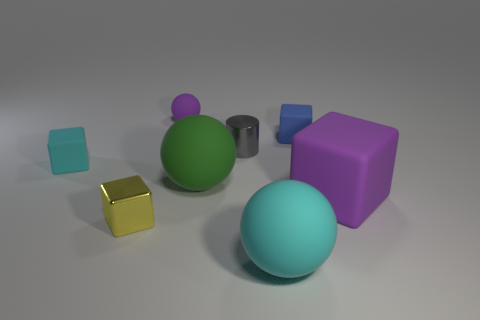There is a tiny ball that is the same color as the big cube; what is its material?
Keep it short and to the point. Rubber. What number of other objects are the same shape as the tiny blue rubber object?
Your answer should be very brief. 3. There is a tiny cube right of the sphere to the left of the green thing in front of the small cyan matte thing; what color is it?
Provide a succinct answer. Blue. How many small things are there?
Provide a short and direct response. 5. How many large things are purple balls or blue metallic cylinders?
Make the answer very short. 0. What is the shape of the purple rubber thing that is the same size as the shiny cube?
Offer a terse response. Sphere. Are there any other things that are the same size as the yellow block?
Offer a terse response. Yes. What is the material of the block that is in front of the purple matte object in front of the small gray shiny cylinder?
Your answer should be very brief. Metal. Do the cyan cube and the yellow cube have the same size?
Give a very brief answer. Yes. What number of objects are either rubber things that are to the left of the small cylinder or large objects?
Your answer should be compact. 5. 